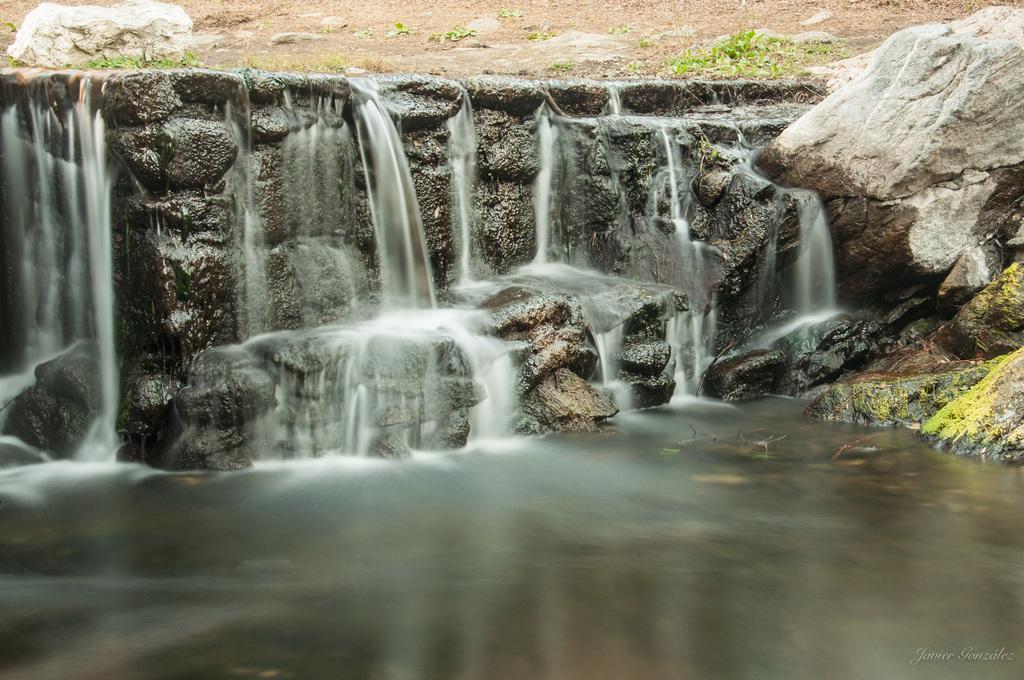How would you summarize this image in a sentence or two? In this picture we can observe water. There is a small waterfall. We can observe stones. There are some plants. In the background there is an open ground. 